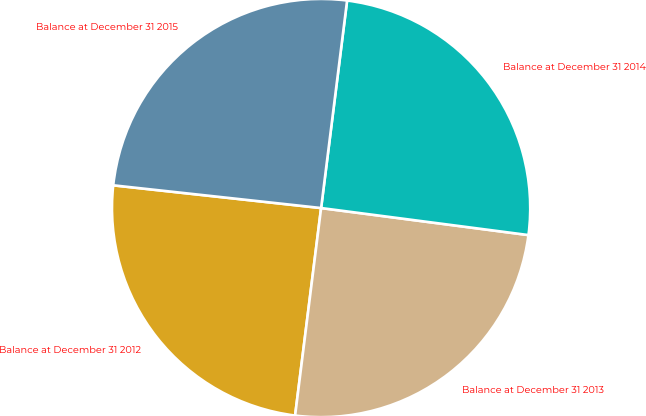Convert chart to OTSL. <chart><loc_0><loc_0><loc_500><loc_500><pie_chart><fcel>Balance at December 31 2012<fcel>Balance at December 31 2013<fcel>Balance at December 31 2014<fcel>Balance at December 31 2015<nl><fcel>24.75%<fcel>24.92%<fcel>25.08%<fcel>25.25%<nl></chart> 